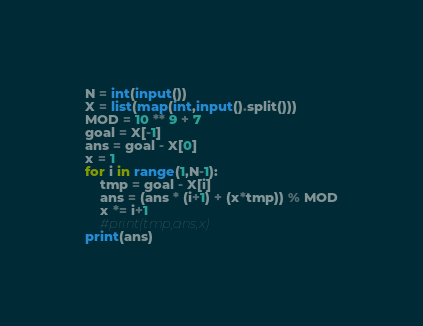Convert code to text. <code><loc_0><loc_0><loc_500><loc_500><_Python_>N = int(input())
X = list(map(int,input().split()))
MOD = 10 ** 9 + 7
goal = X[-1]
ans = goal - X[0]
x = 1
for i in range(1,N-1):
    tmp = goal - X[i]
    ans = (ans * (i+1) + (x*tmp)) % MOD
    x *= i+1
    #print(tmp,ans,x)
print(ans)</code> 